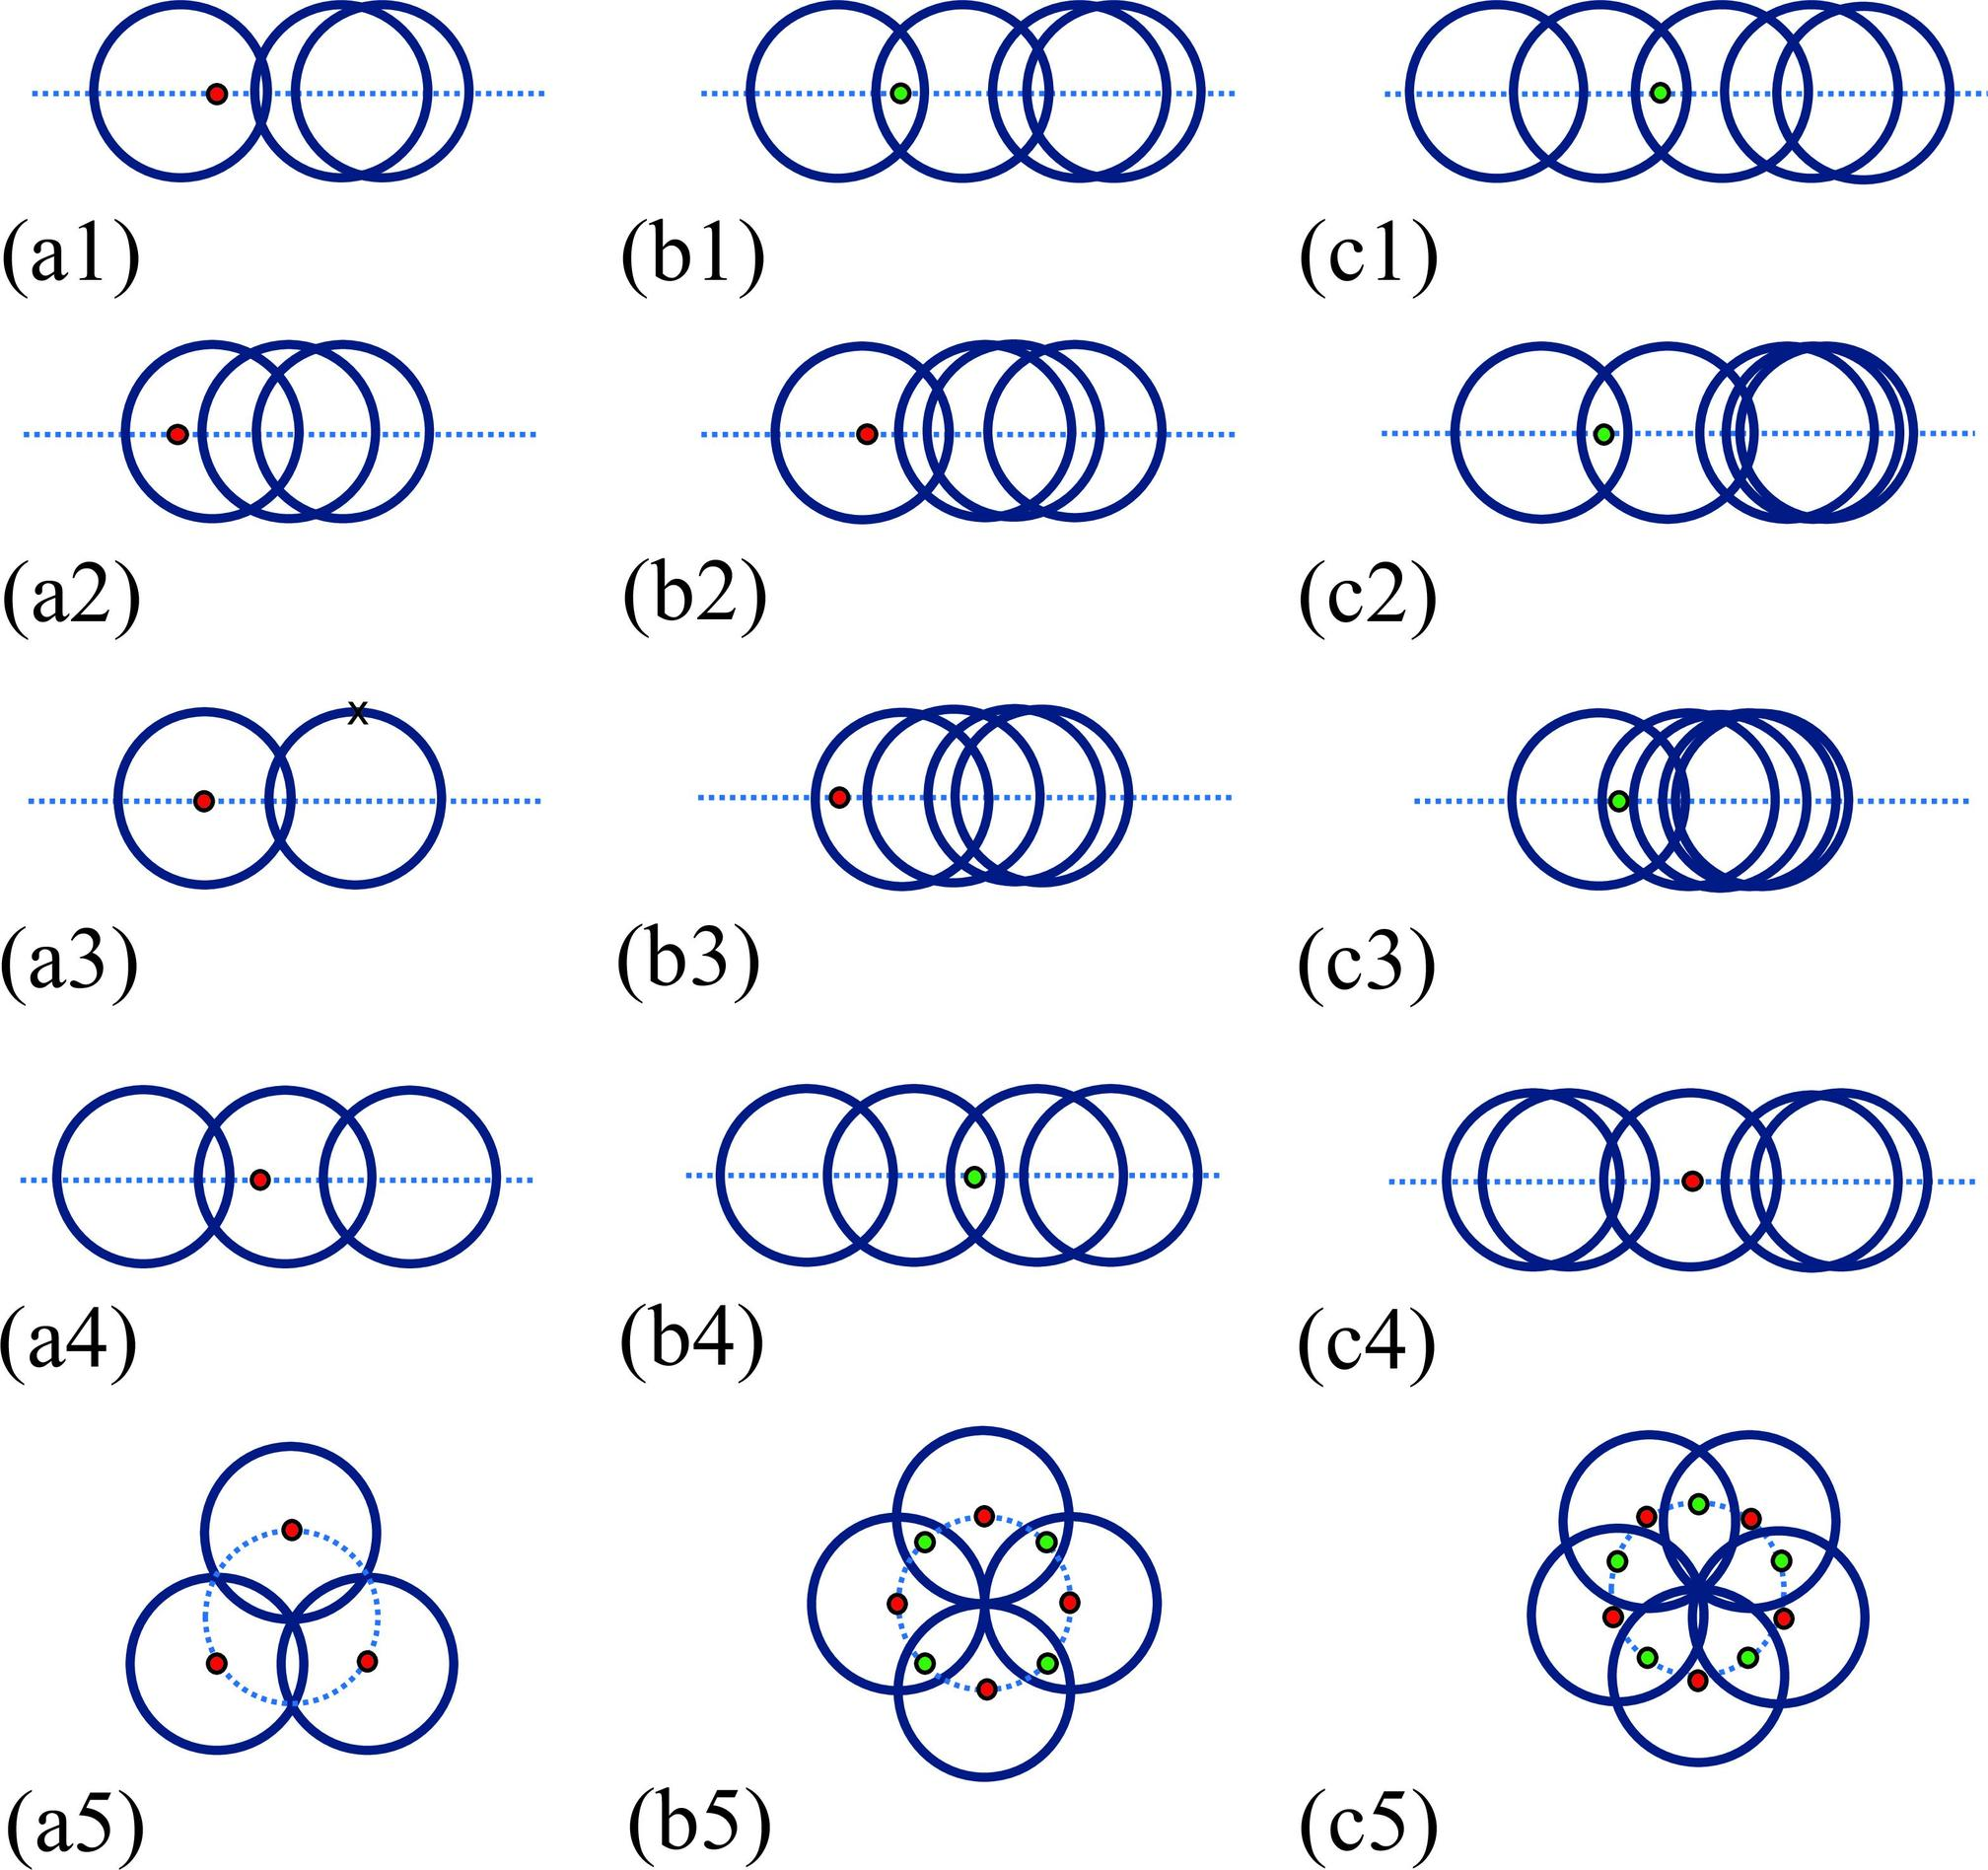Based on figures c1 to c3, what is the role of the blue circles in relation to the red and green dots? A. The blue circles are generating the dots. B. The blue circles are moving independently of the dots. C. The blue circles are controlling the movement of the dots. D. The blue circles and dots are part of a feedback loop. The consistent arrangement of blue circles around the dots suggests an interactive relationship, possibly a feedback loop, where each affects the other's behavior. Therefore, the correct answer is D. 